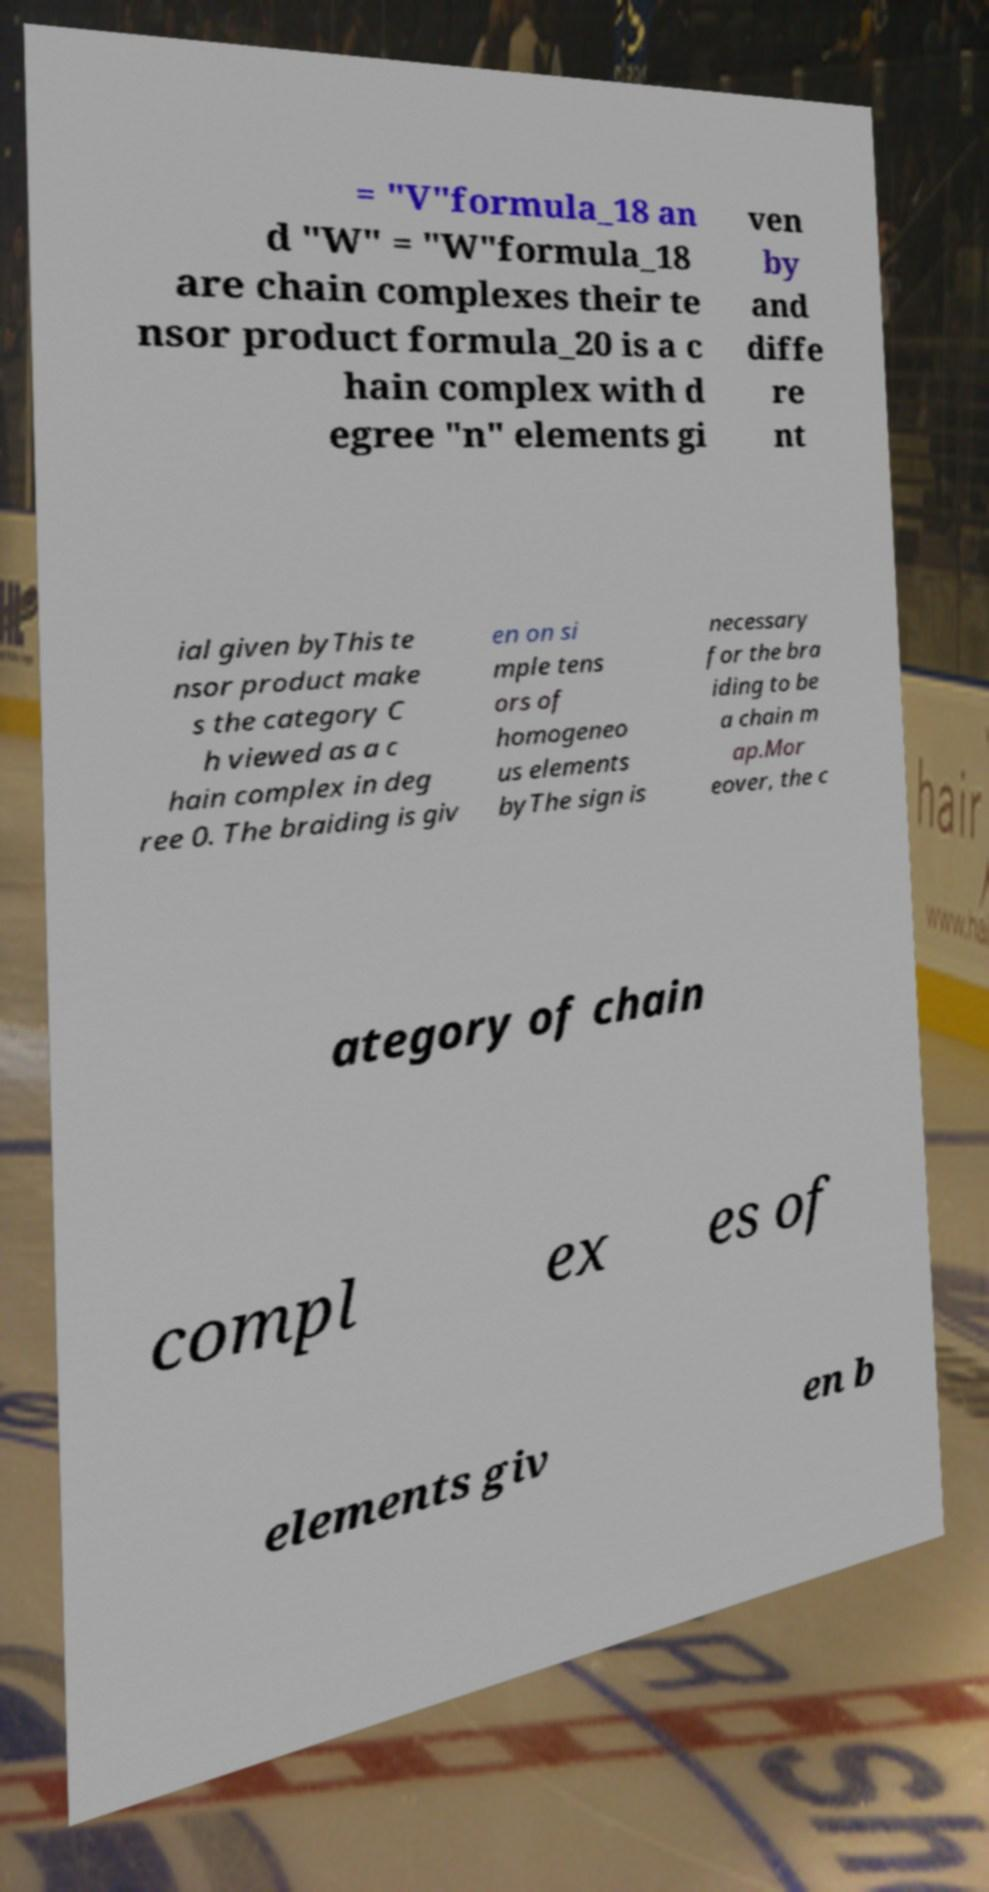Can you read and provide the text displayed in the image?This photo seems to have some interesting text. Can you extract and type it out for me? = "V"formula_18 an d "W" = "W"formula_18 are chain complexes their te nsor product formula_20 is a c hain complex with d egree "n" elements gi ven by and diffe re nt ial given byThis te nsor product make s the category C h viewed as a c hain complex in deg ree 0. The braiding is giv en on si mple tens ors of homogeneo us elements byThe sign is necessary for the bra iding to be a chain m ap.Mor eover, the c ategory of chain compl ex es of elements giv en b 